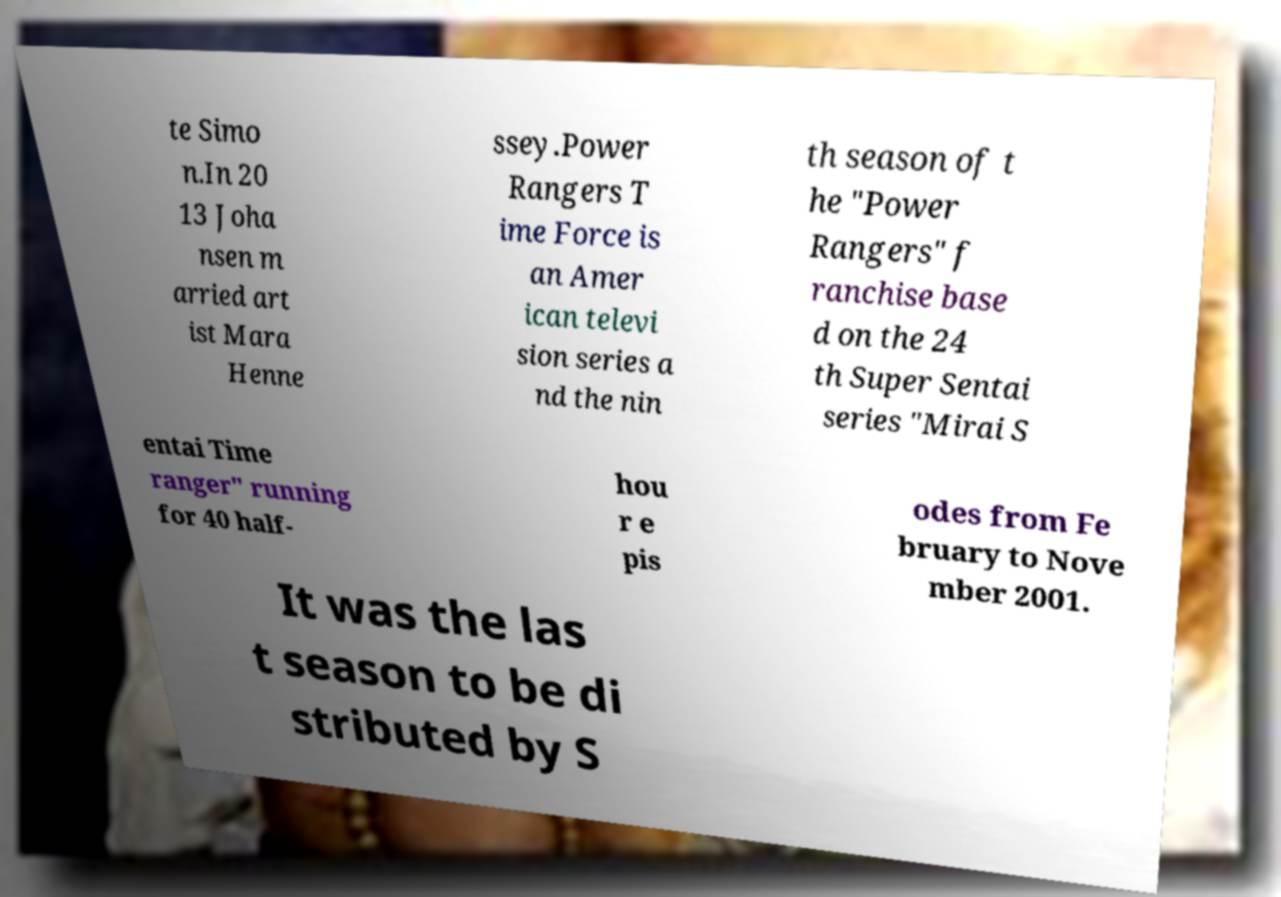Please read and relay the text visible in this image. What does it say? te Simo n.In 20 13 Joha nsen m arried art ist Mara Henne ssey.Power Rangers T ime Force is an Amer ican televi sion series a nd the nin th season of t he "Power Rangers" f ranchise base d on the 24 th Super Sentai series "Mirai S entai Time ranger" running for 40 half- hou r e pis odes from Fe bruary to Nove mber 2001. It was the las t season to be di stributed by S 